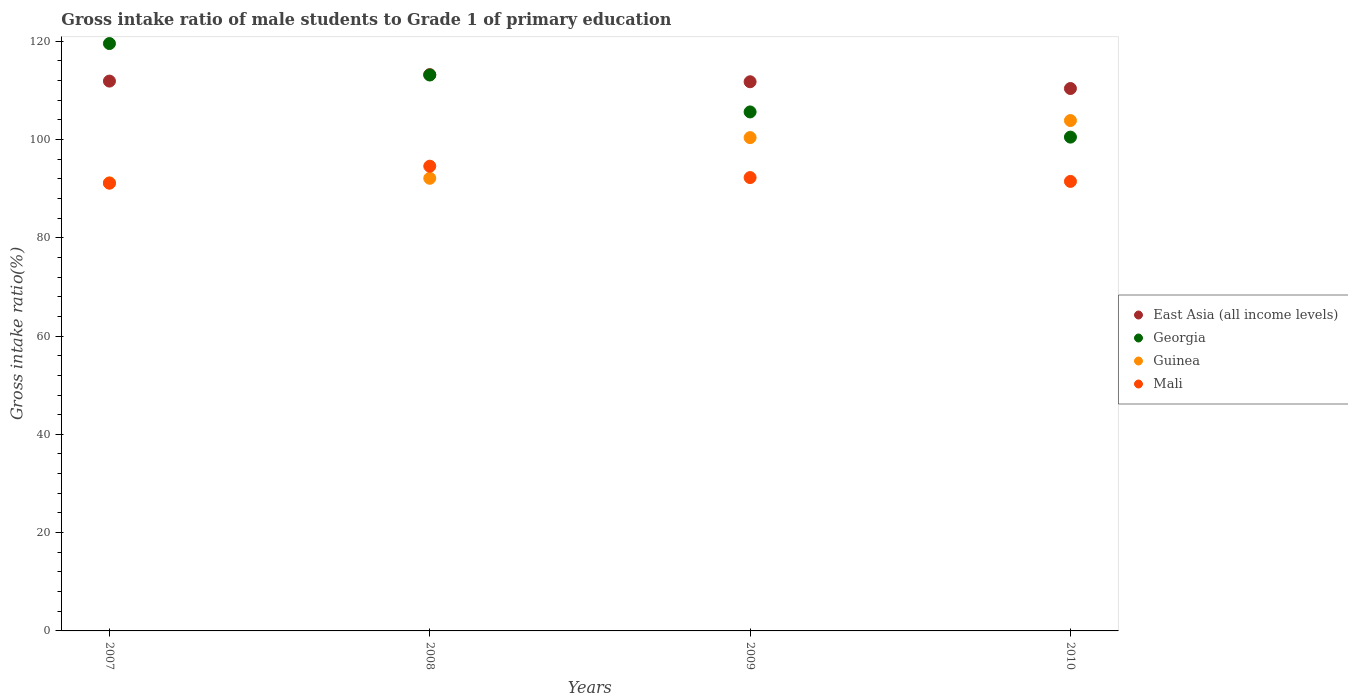How many different coloured dotlines are there?
Ensure brevity in your answer.  4. Is the number of dotlines equal to the number of legend labels?
Your response must be concise. Yes. What is the gross intake ratio in Guinea in 2009?
Your answer should be compact. 100.37. Across all years, what is the maximum gross intake ratio in East Asia (all income levels)?
Offer a very short reply. 113.19. Across all years, what is the minimum gross intake ratio in Mali?
Give a very brief answer. 91.1. In which year was the gross intake ratio in East Asia (all income levels) minimum?
Provide a succinct answer. 2010. What is the total gross intake ratio in Georgia in the graph?
Make the answer very short. 438.7. What is the difference between the gross intake ratio in Guinea in 2007 and that in 2010?
Make the answer very short. -12.68. What is the difference between the gross intake ratio in Guinea in 2010 and the gross intake ratio in Georgia in 2007?
Make the answer very short. -15.66. What is the average gross intake ratio in Guinea per year?
Provide a succinct answer. 96.87. In the year 2010, what is the difference between the gross intake ratio in Guinea and gross intake ratio in Georgia?
Your answer should be very brief. 3.37. In how many years, is the gross intake ratio in Guinea greater than 88 %?
Keep it short and to the point. 4. What is the ratio of the gross intake ratio in Georgia in 2008 to that in 2009?
Offer a very short reply. 1.07. Is the gross intake ratio in Guinea in 2007 less than that in 2009?
Keep it short and to the point. Yes. What is the difference between the highest and the second highest gross intake ratio in East Asia (all income levels)?
Your answer should be compact. 1.32. What is the difference between the highest and the lowest gross intake ratio in Georgia?
Ensure brevity in your answer.  19.04. Is the sum of the gross intake ratio in East Asia (all income levels) in 2008 and 2010 greater than the maximum gross intake ratio in Georgia across all years?
Provide a succinct answer. Yes. Is it the case that in every year, the sum of the gross intake ratio in Mali and gross intake ratio in Guinea  is greater than the sum of gross intake ratio in Georgia and gross intake ratio in East Asia (all income levels)?
Offer a terse response. No. Is the gross intake ratio in Mali strictly greater than the gross intake ratio in East Asia (all income levels) over the years?
Provide a succinct answer. No. Is the gross intake ratio in Guinea strictly less than the gross intake ratio in East Asia (all income levels) over the years?
Make the answer very short. Yes. How many dotlines are there?
Provide a succinct answer. 4. How many years are there in the graph?
Your answer should be compact. 4. What is the difference between two consecutive major ticks on the Y-axis?
Your answer should be compact. 20. Are the values on the major ticks of Y-axis written in scientific E-notation?
Keep it short and to the point. No. Does the graph contain any zero values?
Ensure brevity in your answer.  No. Where does the legend appear in the graph?
Provide a succinct answer. Center right. How many legend labels are there?
Provide a succinct answer. 4. How are the legend labels stacked?
Provide a short and direct response. Vertical. What is the title of the graph?
Your response must be concise. Gross intake ratio of male students to Grade 1 of primary education. What is the label or title of the X-axis?
Provide a short and direct response. Years. What is the label or title of the Y-axis?
Provide a succinct answer. Gross intake ratio(%). What is the Gross intake ratio(%) of East Asia (all income levels) in 2007?
Your answer should be very brief. 111.87. What is the Gross intake ratio(%) of Georgia in 2007?
Your answer should be very brief. 119.51. What is the Gross intake ratio(%) in Guinea in 2007?
Provide a short and direct response. 91.17. What is the Gross intake ratio(%) of Mali in 2007?
Your response must be concise. 91.1. What is the Gross intake ratio(%) of East Asia (all income levels) in 2008?
Provide a short and direct response. 113.19. What is the Gross intake ratio(%) of Georgia in 2008?
Provide a succinct answer. 113.11. What is the Gross intake ratio(%) in Guinea in 2008?
Provide a succinct answer. 92.1. What is the Gross intake ratio(%) of Mali in 2008?
Give a very brief answer. 94.56. What is the Gross intake ratio(%) of East Asia (all income levels) in 2009?
Keep it short and to the point. 111.74. What is the Gross intake ratio(%) in Georgia in 2009?
Your answer should be compact. 105.6. What is the Gross intake ratio(%) in Guinea in 2009?
Provide a succinct answer. 100.37. What is the Gross intake ratio(%) in Mali in 2009?
Make the answer very short. 92.24. What is the Gross intake ratio(%) of East Asia (all income levels) in 2010?
Offer a very short reply. 110.36. What is the Gross intake ratio(%) in Georgia in 2010?
Your answer should be compact. 100.48. What is the Gross intake ratio(%) in Guinea in 2010?
Your answer should be compact. 103.85. What is the Gross intake ratio(%) in Mali in 2010?
Offer a terse response. 91.46. Across all years, what is the maximum Gross intake ratio(%) of East Asia (all income levels)?
Offer a very short reply. 113.19. Across all years, what is the maximum Gross intake ratio(%) in Georgia?
Your response must be concise. 119.51. Across all years, what is the maximum Gross intake ratio(%) in Guinea?
Your answer should be compact. 103.85. Across all years, what is the maximum Gross intake ratio(%) of Mali?
Offer a very short reply. 94.56. Across all years, what is the minimum Gross intake ratio(%) of East Asia (all income levels)?
Offer a very short reply. 110.36. Across all years, what is the minimum Gross intake ratio(%) in Georgia?
Keep it short and to the point. 100.48. Across all years, what is the minimum Gross intake ratio(%) of Guinea?
Your answer should be very brief. 91.17. Across all years, what is the minimum Gross intake ratio(%) of Mali?
Ensure brevity in your answer.  91.1. What is the total Gross intake ratio(%) in East Asia (all income levels) in the graph?
Give a very brief answer. 447.16. What is the total Gross intake ratio(%) of Georgia in the graph?
Give a very brief answer. 438.7. What is the total Gross intake ratio(%) in Guinea in the graph?
Give a very brief answer. 387.48. What is the total Gross intake ratio(%) in Mali in the graph?
Provide a short and direct response. 369.37. What is the difference between the Gross intake ratio(%) of East Asia (all income levels) in 2007 and that in 2008?
Give a very brief answer. -1.32. What is the difference between the Gross intake ratio(%) in Georgia in 2007 and that in 2008?
Offer a terse response. 6.4. What is the difference between the Gross intake ratio(%) in Guinea in 2007 and that in 2008?
Give a very brief answer. -0.93. What is the difference between the Gross intake ratio(%) in Mali in 2007 and that in 2008?
Offer a terse response. -3.46. What is the difference between the Gross intake ratio(%) of East Asia (all income levels) in 2007 and that in 2009?
Keep it short and to the point. 0.13. What is the difference between the Gross intake ratio(%) in Georgia in 2007 and that in 2009?
Keep it short and to the point. 13.91. What is the difference between the Gross intake ratio(%) of Guinea in 2007 and that in 2009?
Your answer should be very brief. -9.2. What is the difference between the Gross intake ratio(%) in Mali in 2007 and that in 2009?
Your answer should be very brief. -1.14. What is the difference between the Gross intake ratio(%) in East Asia (all income levels) in 2007 and that in 2010?
Make the answer very short. 1.51. What is the difference between the Gross intake ratio(%) of Georgia in 2007 and that in 2010?
Your answer should be very brief. 19.04. What is the difference between the Gross intake ratio(%) of Guinea in 2007 and that in 2010?
Keep it short and to the point. -12.68. What is the difference between the Gross intake ratio(%) in Mali in 2007 and that in 2010?
Make the answer very short. -0.36. What is the difference between the Gross intake ratio(%) of East Asia (all income levels) in 2008 and that in 2009?
Offer a very short reply. 1.45. What is the difference between the Gross intake ratio(%) of Georgia in 2008 and that in 2009?
Make the answer very short. 7.52. What is the difference between the Gross intake ratio(%) of Guinea in 2008 and that in 2009?
Provide a short and direct response. -8.27. What is the difference between the Gross intake ratio(%) in Mali in 2008 and that in 2009?
Ensure brevity in your answer.  2.32. What is the difference between the Gross intake ratio(%) of East Asia (all income levels) in 2008 and that in 2010?
Ensure brevity in your answer.  2.82. What is the difference between the Gross intake ratio(%) of Georgia in 2008 and that in 2010?
Offer a very short reply. 12.64. What is the difference between the Gross intake ratio(%) in Guinea in 2008 and that in 2010?
Your response must be concise. -11.75. What is the difference between the Gross intake ratio(%) of Mali in 2008 and that in 2010?
Provide a succinct answer. 3.1. What is the difference between the Gross intake ratio(%) in East Asia (all income levels) in 2009 and that in 2010?
Give a very brief answer. 1.37. What is the difference between the Gross intake ratio(%) of Georgia in 2009 and that in 2010?
Offer a terse response. 5.12. What is the difference between the Gross intake ratio(%) of Guinea in 2009 and that in 2010?
Provide a succinct answer. -3.48. What is the difference between the Gross intake ratio(%) in Mali in 2009 and that in 2010?
Ensure brevity in your answer.  0.78. What is the difference between the Gross intake ratio(%) of East Asia (all income levels) in 2007 and the Gross intake ratio(%) of Georgia in 2008?
Your answer should be compact. -1.24. What is the difference between the Gross intake ratio(%) in East Asia (all income levels) in 2007 and the Gross intake ratio(%) in Guinea in 2008?
Your answer should be compact. 19.78. What is the difference between the Gross intake ratio(%) of East Asia (all income levels) in 2007 and the Gross intake ratio(%) of Mali in 2008?
Your response must be concise. 17.31. What is the difference between the Gross intake ratio(%) in Georgia in 2007 and the Gross intake ratio(%) in Guinea in 2008?
Your response must be concise. 27.41. What is the difference between the Gross intake ratio(%) of Georgia in 2007 and the Gross intake ratio(%) of Mali in 2008?
Give a very brief answer. 24.95. What is the difference between the Gross intake ratio(%) of Guinea in 2007 and the Gross intake ratio(%) of Mali in 2008?
Provide a short and direct response. -3.39. What is the difference between the Gross intake ratio(%) of East Asia (all income levels) in 2007 and the Gross intake ratio(%) of Georgia in 2009?
Offer a very short reply. 6.27. What is the difference between the Gross intake ratio(%) in East Asia (all income levels) in 2007 and the Gross intake ratio(%) in Guinea in 2009?
Make the answer very short. 11.5. What is the difference between the Gross intake ratio(%) in East Asia (all income levels) in 2007 and the Gross intake ratio(%) in Mali in 2009?
Your answer should be compact. 19.63. What is the difference between the Gross intake ratio(%) of Georgia in 2007 and the Gross intake ratio(%) of Guinea in 2009?
Provide a short and direct response. 19.14. What is the difference between the Gross intake ratio(%) of Georgia in 2007 and the Gross intake ratio(%) of Mali in 2009?
Provide a succinct answer. 27.27. What is the difference between the Gross intake ratio(%) of Guinea in 2007 and the Gross intake ratio(%) of Mali in 2009?
Provide a succinct answer. -1.08. What is the difference between the Gross intake ratio(%) in East Asia (all income levels) in 2007 and the Gross intake ratio(%) in Georgia in 2010?
Provide a succinct answer. 11.4. What is the difference between the Gross intake ratio(%) in East Asia (all income levels) in 2007 and the Gross intake ratio(%) in Guinea in 2010?
Your answer should be compact. 8.03. What is the difference between the Gross intake ratio(%) in East Asia (all income levels) in 2007 and the Gross intake ratio(%) in Mali in 2010?
Offer a terse response. 20.41. What is the difference between the Gross intake ratio(%) of Georgia in 2007 and the Gross intake ratio(%) of Guinea in 2010?
Your answer should be compact. 15.66. What is the difference between the Gross intake ratio(%) of Georgia in 2007 and the Gross intake ratio(%) of Mali in 2010?
Ensure brevity in your answer.  28.05. What is the difference between the Gross intake ratio(%) of Guinea in 2007 and the Gross intake ratio(%) of Mali in 2010?
Ensure brevity in your answer.  -0.29. What is the difference between the Gross intake ratio(%) of East Asia (all income levels) in 2008 and the Gross intake ratio(%) of Georgia in 2009?
Give a very brief answer. 7.59. What is the difference between the Gross intake ratio(%) in East Asia (all income levels) in 2008 and the Gross intake ratio(%) in Guinea in 2009?
Keep it short and to the point. 12.82. What is the difference between the Gross intake ratio(%) in East Asia (all income levels) in 2008 and the Gross intake ratio(%) in Mali in 2009?
Provide a short and direct response. 20.94. What is the difference between the Gross intake ratio(%) in Georgia in 2008 and the Gross intake ratio(%) in Guinea in 2009?
Your answer should be very brief. 12.74. What is the difference between the Gross intake ratio(%) in Georgia in 2008 and the Gross intake ratio(%) in Mali in 2009?
Keep it short and to the point. 20.87. What is the difference between the Gross intake ratio(%) of Guinea in 2008 and the Gross intake ratio(%) of Mali in 2009?
Give a very brief answer. -0.15. What is the difference between the Gross intake ratio(%) in East Asia (all income levels) in 2008 and the Gross intake ratio(%) in Georgia in 2010?
Make the answer very short. 12.71. What is the difference between the Gross intake ratio(%) in East Asia (all income levels) in 2008 and the Gross intake ratio(%) in Guinea in 2010?
Ensure brevity in your answer.  9.34. What is the difference between the Gross intake ratio(%) in East Asia (all income levels) in 2008 and the Gross intake ratio(%) in Mali in 2010?
Offer a very short reply. 21.73. What is the difference between the Gross intake ratio(%) of Georgia in 2008 and the Gross intake ratio(%) of Guinea in 2010?
Offer a very short reply. 9.27. What is the difference between the Gross intake ratio(%) in Georgia in 2008 and the Gross intake ratio(%) in Mali in 2010?
Offer a very short reply. 21.65. What is the difference between the Gross intake ratio(%) of Guinea in 2008 and the Gross intake ratio(%) of Mali in 2010?
Offer a very short reply. 0.63. What is the difference between the Gross intake ratio(%) in East Asia (all income levels) in 2009 and the Gross intake ratio(%) in Georgia in 2010?
Provide a short and direct response. 11.26. What is the difference between the Gross intake ratio(%) in East Asia (all income levels) in 2009 and the Gross intake ratio(%) in Guinea in 2010?
Provide a succinct answer. 7.89. What is the difference between the Gross intake ratio(%) of East Asia (all income levels) in 2009 and the Gross intake ratio(%) of Mali in 2010?
Provide a short and direct response. 20.28. What is the difference between the Gross intake ratio(%) of Georgia in 2009 and the Gross intake ratio(%) of Guinea in 2010?
Make the answer very short. 1.75. What is the difference between the Gross intake ratio(%) in Georgia in 2009 and the Gross intake ratio(%) in Mali in 2010?
Offer a very short reply. 14.14. What is the difference between the Gross intake ratio(%) of Guinea in 2009 and the Gross intake ratio(%) of Mali in 2010?
Provide a succinct answer. 8.91. What is the average Gross intake ratio(%) of East Asia (all income levels) per year?
Offer a very short reply. 111.79. What is the average Gross intake ratio(%) of Georgia per year?
Your answer should be very brief. 109.68. What is the average Gross intake ratio(%) of Guinea per year?
Offer a very short reply. 96.87. What is the average Gross intake ratio(%) in Mali per year?
Make the answer very short. 92.34. In the year 2007, what is the difference between the Gross intake ratio(%) in East Asia (all income levels) and Gross intake ratio(%) in Georgia?
Keep it short and to the point. -7.64. In the year 2007, what is the difference between the Gross intake ratio(%) in East Asia (all income levels) and Gross intake ratio(%) in Guinea?
Keep it short and to the point. 20.7. In the year 2007, what is the difference between the Gross intake ratio(%) of East Asia (all income levels) and Gross intake ratio(%) of Mali?
Offer a terse response. 20.77. In the year 2007, what is the difference between the Gross intake ratio(%) in Georgia and Gross intake ratio(%) in Guinea?
Give a very brief answer. 28.34. In the year 2007, what is the difference between the Gross intake ratio(%) in Georgia and Gross intake ratio(%) in Mali?
Give a very brief answer. 28.41. In the year 2007, what is the difference between the Gross intake ratio(%) of Guinea and Gross intake ratio(%) of Mali?
Offer a terse response. 0.07. In the year 2008, what is the difference between the Gross intake ratio(%) of East Asia (all income levels) and Gross intake ratio(%) of Georgia?
Make the answer very short. 0.07. In the year 2008, what is the difference between the Gross intake ratio(%) of East Asia (all income levels) and Gross intake ratio(%) of Guinea?
Provide a short and direct response. 21.09. In the year 2008, what is the difference between the Gross intake ratio(%) of East Asia (all income levels) and Gross intake ratio(%) of Mali?
Keep it short and to the point. 18.63. In the year 2008, what is the difference between the Gross intake ratio(%) in Georgia and Gross intake ratio(%) in Guinea?
Offer a terse response. 21.02. In the year 2008, what is the difference between the Gross intake ratio(%) of Georgia and Gross intake ratio(%) of Mali?
Your response must be concise. 18.55. In the year 2008, what is the difference between the Gross intake ratio(%) of Guinea and Gross intake ratio(%) of Mali?
Provide a succinct answer. -2.46. In the year 2009, what is the difference between the Gross intake ratio(%) in East Asia (all income levels) and Gross intake ratio(%) in Georgia?
Your answer should be very brief. 6.14. In the year 2009, what is the difference between the Gross intake ratio(%) in East Asia (all income levels) and Gross intake ratio(%) in Guinea?
Your response must be concise. 11.37. In the year 2009, what is the difference between the Gross intake ratio(%) of East Asia (all income levels) and Gross intake ratio(%) of Mali?
Your answer should be very brief. 19.49. In the year 2009, what is the difference between the Gross intake ratio(%) of Georgia and Gross intake ratio(%) of Guinea?
Provide a succinct answer. 5.23. In the year 2009, what is the difference between the Gross intake ratio(%) of Georgia and Gross intake ratio(%) of Mali?
Your response must be concise. 13.35. In the year 2009, what is the difference between the Gross intake ratio(%) of Guinea and Gross intake ratio(%) of Mali?
Your answer should be compact. 8.13. In the year 2010, what is the difference between the Gross intake ratio(%) in East Asia (all income levels) and Gross intake ratio(%) in Georgia?
Ensure brevity in your answer.  9.89. In the year 2010, what is the difference between the Gross intake ratio(%) of East Asia (all income levels) and Gross intake ratio(%) of Guinea?
Provide a short and direct response. 6.52. In the year 2010, what is the difference between the Gross intake ratio(%) in East Asia (all income levels) and Gross intake ratio(%) in Mali?
Offer a terse response. 18.9. In the year 2010, what is the difference between the Gross intake ratio(%) in Georgia and Gross intake ratio(%) in Guinea?
Your response must be concise. -3.37. In the year 2010, what is the difference between the Gross intake ratio(%) of Georgia and Gross intake ratio(%) of Mali?
Make the answer very short. 9.01. In the year 2010, what is the difference between the Gross intake ratio(%) of Guinea and Gross intake ratio(%) of Mali?
Provide a succinct answer. 12.38. What is the ratio of the Gross intake ratio(%) in East Asia (all income levels) in 2007 to that in 2008?
Make the answer very short. 0.99. What is the ratio of the Gross intake ratio(%) of Georgia in 2007 to that in 2008?
Offer a very short reply. 1.06. What is the ratio of the Gross intake ratio(%) of Guinea in 2007 to that in 2008?
Your answer should be very brief. 0.99. What is the ratio of the Gross intake ratio(%) of Mali in 2007 to that in 2008?
Offer a terse response. 0.96. What is the ratio of the Gross intake ratio(%) of East Asia (all income levels) in 2007 to that in 2009?
Offer a terse response. 1. What is the ratio of the Gross intake ratio(%) of Georgia in 2007 to that in 2009?
Your answer should be very brief. 1.13. What is the ratio of the Gross intake ratio(%) in Guinea in 2007 to that in 2009?
Ensure brevity in your answer.  0.91. What is the ratio of the Gross intake ratio(%) of Mali in 2007 to that in 2009?
Keep it short and to the point. 0.99. What is the ratio of the Gross intake ratio(%) in East Asia (all income levels) in 2007 to that in 2010?
Make the answer very short. 1.01. What is the ratio of the Gross intake ratio(%) in Georgia in 2007 to that in 2010?
Give a very brief answer. 1.19. What is the ratio of the Gross intake ratio(%) of Guinea in 2007 to that in 2010?
Your answer should be compact. 0.88. What is the ratio of the Gross intake ratio(%) of Georgia in 2008 to that in 2009?
Provide a short and direct response. 1.07. What is the ratio of the Gross intake ratio(%) of Guinea in 2008 to that in 2009?
Provide a succinct answer. 0.92. What is the ratio of the Gross intake ratio(%) in Mali in 2008 to that in 2009?
Offer a very short reply. 1.03. What is the ratio of the Gross intake ratio(%) of East Asia (all income levels) in 2008 to that in 2010?
Offer a very short reply. 1.03. What is the ratio of the Gross intake ratio(%) of Georgia in 2008 to that in 2010?
Provide a succinct answer. 1.13. What is the ratio of the Gross intake ratio(%) in Guinea in 2008 to that in 2010?
Your answer should be compact. 0.89. What is the ratio of the Gross intake ratio(%) of Mali in 2008 to that in 2010?
Provide a short and direct response. 1.03. What is the ratio of the Gross intake ratio(%) in East Asia (all income levels) in 2009 to that in 2010?
Offer a terse response. 1.01. What is the ratio of the Gross intake ratio(%) in Georgia in 2009 to that in 2010?
Your answer should be very brief. 1.05. What is the ratio of the Gross intake ratio(%) in Guinea in 2009 to that in 2010?
Provide a short and direct response. 0.97. What is the ratio of the Gross intake ratio(%) in Mali in 2009 to that in 2010?
Give a very brief answer. 1.01. What is the difference between the highest and the second highest Gross intake ratio(%) in East Asia (all income levels)?
Keep it short and to the point. 1.32. What is the difference between the highest and the second highest Gross intake ratio(%) of Georgia?
Your answer should be very brief. 6.4. What is the difference between the highest and the second highest Gross intake ratio(%) of Guinea?
Your response must be concise. 3.48. What is the difference between the highest and the second highest Gross intake ratio(%) of Mali?
Make the answer very short. 2.32. What is the difference between the highest and the lowest Gross intake ratio(%) in East Asia (all income levels)?
Make the answer very short. 2.82. What is the difference between the highest and the lowest Gross intake ratio(%) of Georgia?
Give a very brief answer. 19.04. What is the difference between the highest and the lowest Gross intake ratio(%) of Guinea?
Offer a very short reply. 12.68. What is the difference between the highest and the lowest Gross intake ratio(%) of Mali?
Offer a terse response. 3.46. 